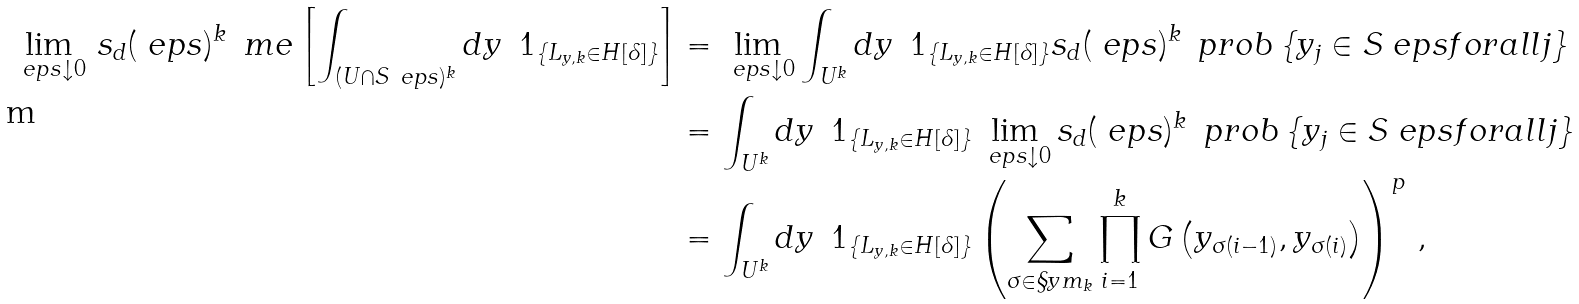<formula> <loc_0><loc_0><loc_500><loc_500>\lim _ { \ e p s \downarrow 0 } \, s _ { d } ( \ e p s ) ^ { k } \, \ m e \left [ \int _ { ( U \cap S _ { \ } e p s ) ^ { k } } d y \, \ 1 _ { \{ L _ { y , k } \in H [ \delta ] \} } \right ] & = \lim _ { \ e p s \downarrow 0 } \int _ { U ^ { k } } d y \, \ 1 _ { \{ L _ { y , k } \in H [ \delta ] \} } s _ { d } ( \ e p s ) ^ { k } \, \ p r o b \left \{ y _ { j } \in S _ { \ } e p s f o r a l l j \right \} \\ & = \int _ { U ^ { k } } d y \, \ 1 _ { \{ L _ { y , k } \in H [ \delta ] \} } \lim _ { \ e p s \downarrow 0 } s _ { d } ( \ e p s ) ^ { k } \, \ p r o b \left \{ y _ { j } \in S _ { \ } e p s f o r a l l j \right \} \\ & = \int _ { U ^ { k } } d y \, \ 1 _ { \{ L _ { y , k } \in H [ \delta ] \} } \left ( \sum _ { \sigma \in \S y m _ { k } } \prod _ { i = 1 } ^ { k } G \left ( y _ { \sigma ( i - 1 ) } , y _ { \sigma ( i ) } \right ) \right ) ^ { p } \, ,</formula> 